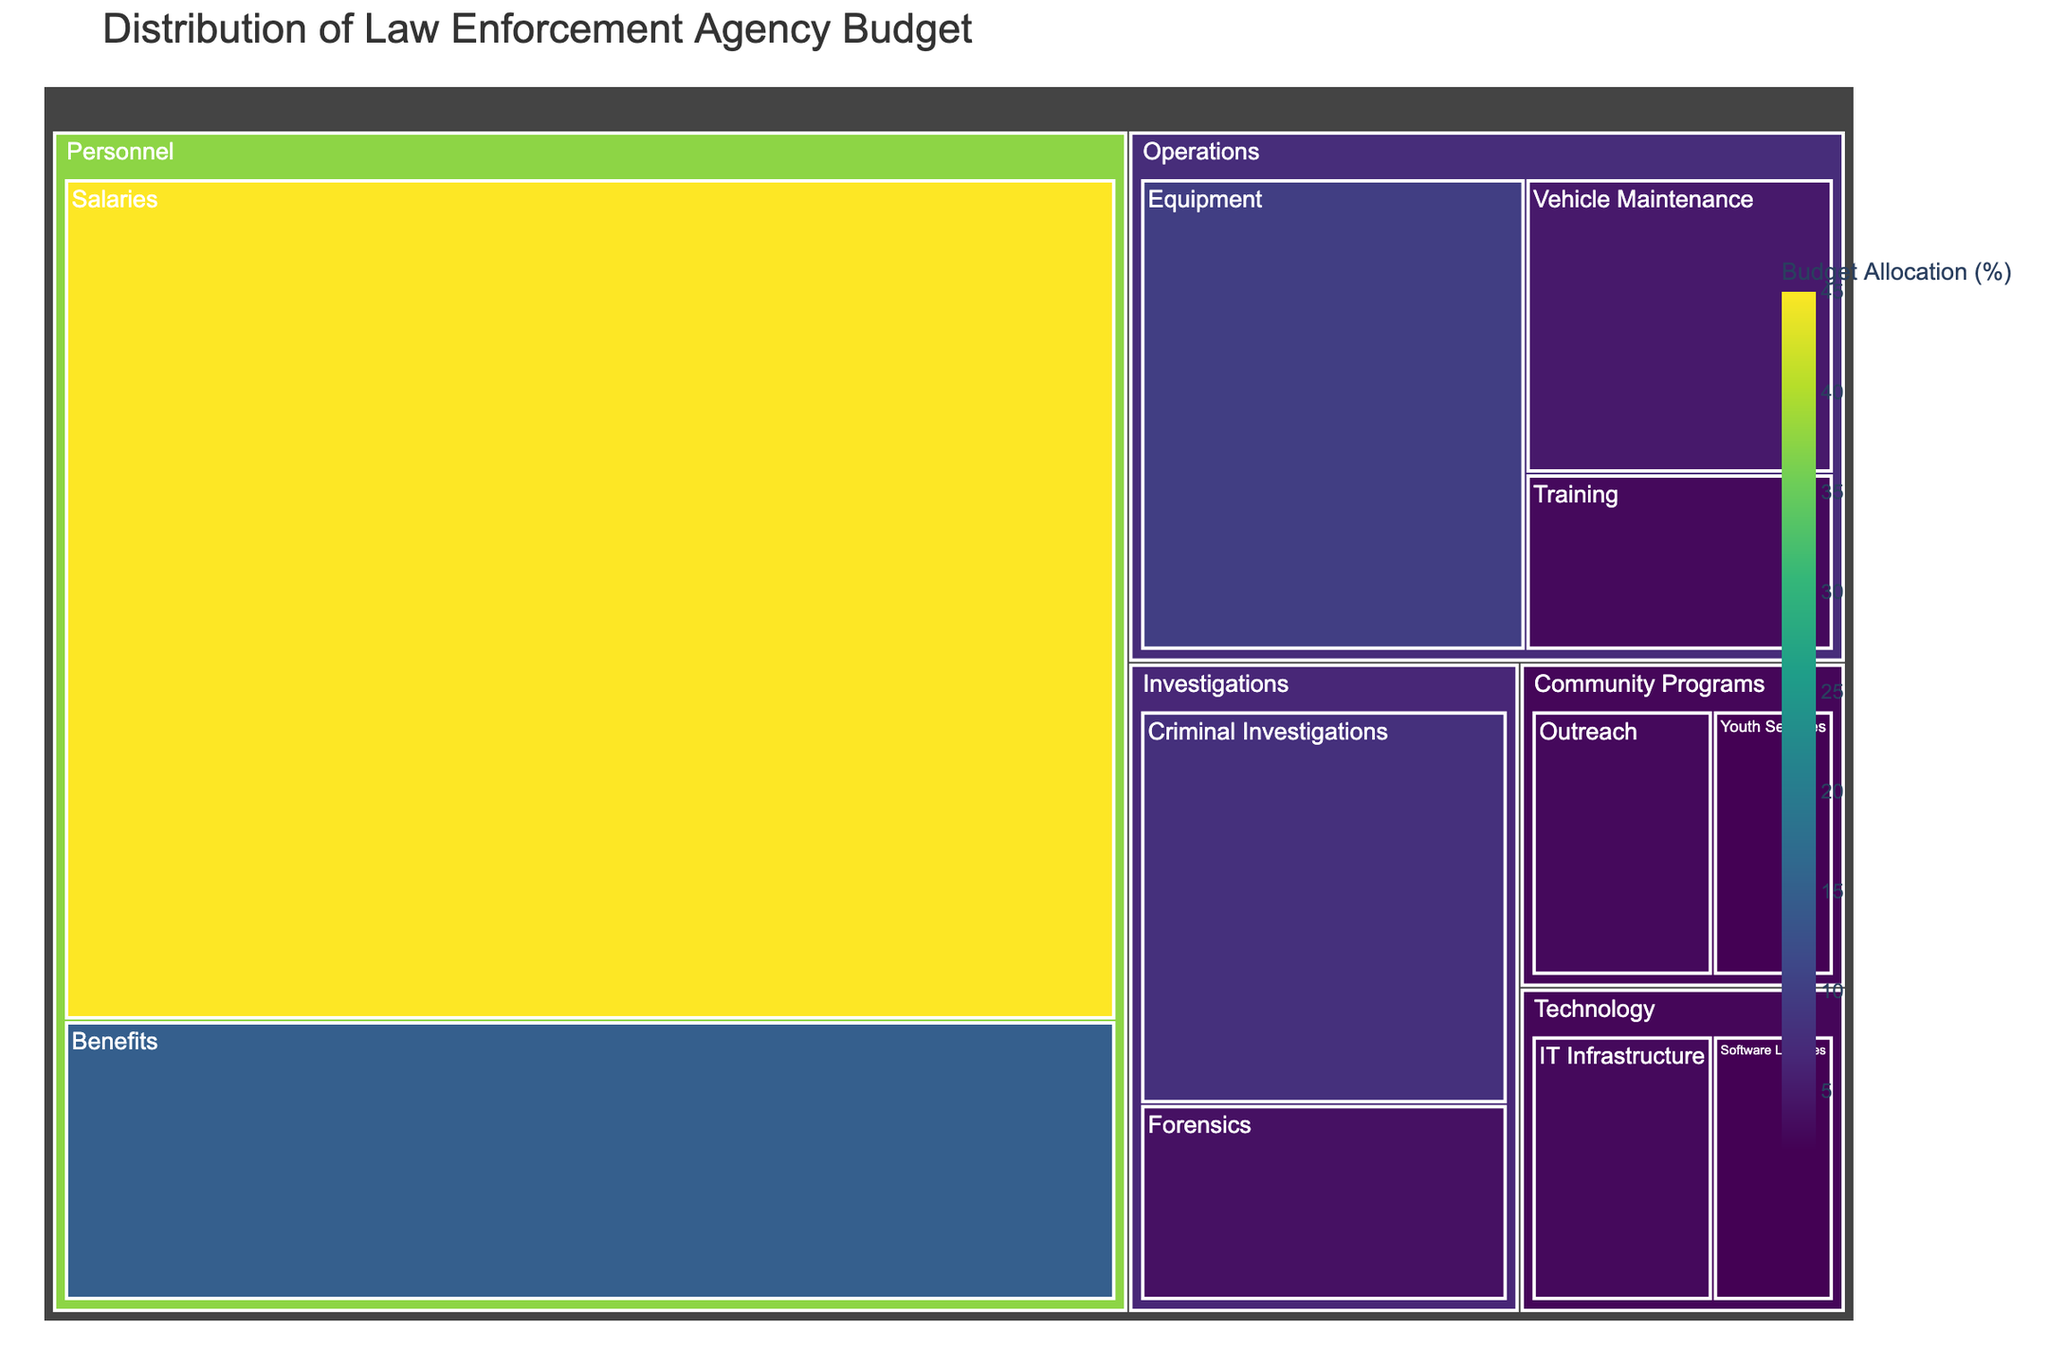What is the total budget allocation for the "Personnel" category? To find the total budget allocation for the "Personnel" category, you need to sum up the budget allocations for "Salaries" and "Benefits" within that category. Salaries have a budget of 45, and Benefits have a budget of 15. So, the total is 45 + 15 = 60
Answer: 60 Which subcategory has the highest budget allocation? Look at the treemap and identify the subcategory with the largest segment. The "Salaries" subcategory under the "Personnel" category has the highest budget allocation of 45%.
Answer: Salaries How does the budget allocation for "Equipment" compare to "Vehicle Maintenance"? Locate the subcategories "Equipment" and "Vehicle Maintenance" in the "Operations" category. "Equipment" has a budget allocation of 10 and "Vehicle Maintenance" has a budget allocation of 5. Therefore, the budget for "Equipment" is 5% greater than "Vehicle Maintenance".
Answer: Equipment has 5% more What is the combined budget allocation for the "Technology" category? Sum the budget allocations for "IT Infrastructure" (3) and "Software Licenses" (2) within the "Technology" category. So, the total is 3 + 2 = 5
Answer: 5 Which category has the smallest total budget allocation? The categories to consider are: Personnel (60), Operations (18), Investigations (12), Community Programs (5), and Technology (5). Both "Community Programs" and "Technology" have the smallest total budget allocation of 5 each.
Answer: Community Programs and Technology What percentage of the budget is allocated to "Criminal Investigations"? In the treemap, locate "Criminal Investigations" under the "Investigations" category. The budget allocation is 8% for "Criminal Investigations".
Answer: 8 How much more is allocated to "Forensics" compared to "Youth Services"? Identify the budget allocations: "Forensics" has a budget allocation of 4 and "Youth Services" has 2. The difference is 4 - 2 = 2. Therefore, "Forensics" is allocated 2% more.
Answer: 2 What is the ratio of the budget allocation of "Salaries" to "Software Licenses"? Divide the budget allocation of "Salaries" (45) by that of "Software Licenses" (2). The ratio is 45 / 2 = 22.5
Answer: 22.5 What is the average budget allocation across all subcategories within the "Operations" category? The subcategories under "Operations" are Equipment (10), Vehicle Maintenance (5), and Training (3). The sum of these allocations is 10 + 5 + 3 = 18. There are 3 subcategories, so the average is 18 / 3 = 6
Answer: 6 How much of the total budget is allocated to "Community Programs" combined? Sum the budget allocations for "Outreach" (3) and "Youth Services" (2) within the "Community Programs" category. The total is 3 + 2 = 5
Answer: 5 